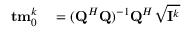Convert formula to latex. <formula><loc_0><loc_0><loc_500><loc_500>\begin{array} { r l } { { t m } _ { 0 } ^ { k } } & = ( { Q } ^ { H } { Q } ) ^ { - 1 } { Q } ^ { H } \sqrt { { I } ^ { k } } } \end{array}</formula> 